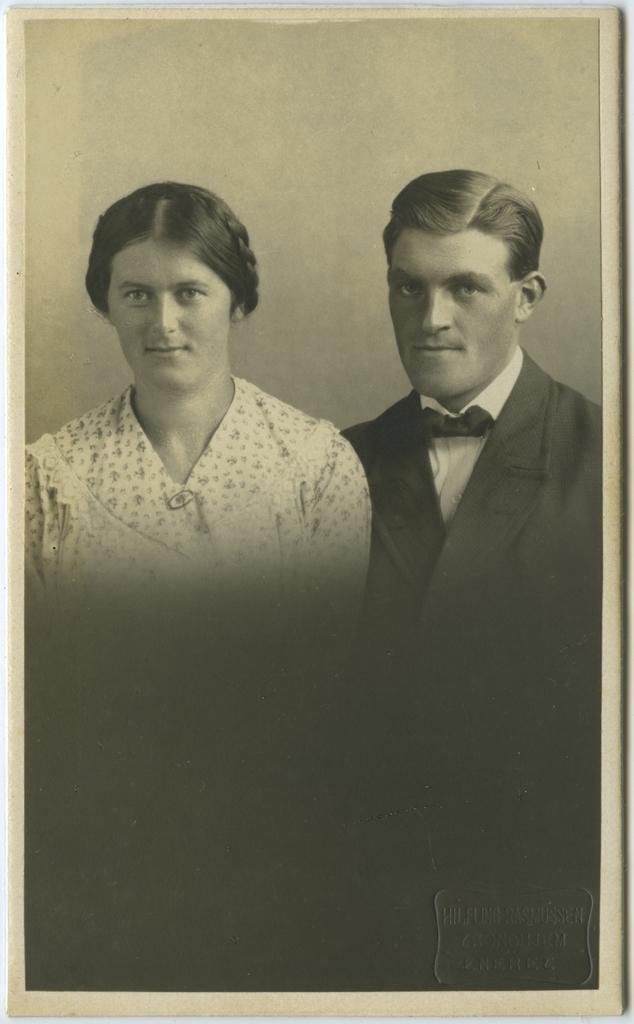Can you describe this image briefly? In this picture there is a man and a woman in the center of the image. 